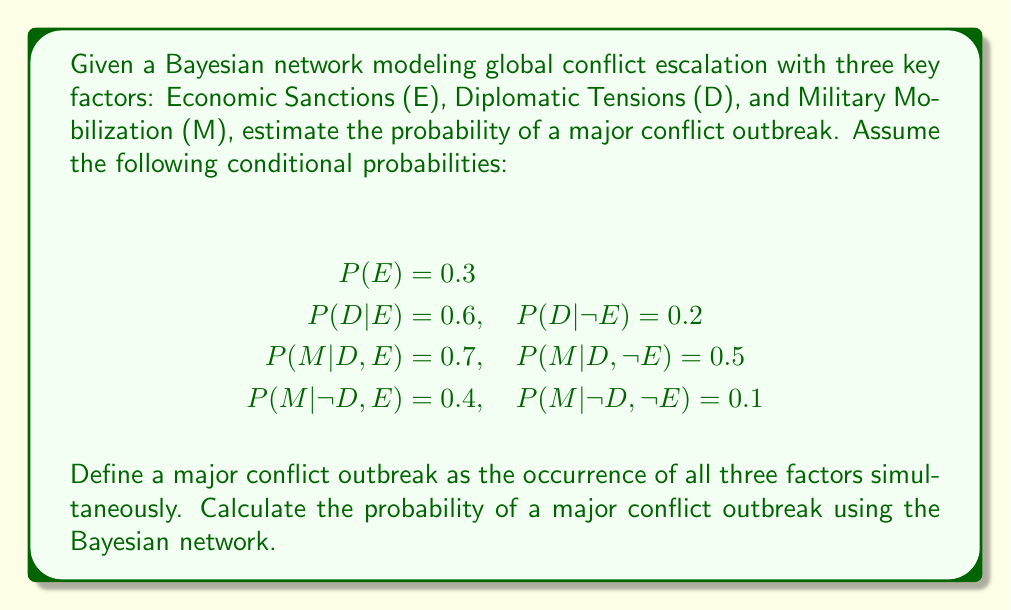Could you help me with this problem? To solve this problem, we'll use the chain rule of probability and the given conditional probabilities in the Bayesian network.

Step 1: Calculate P(E,D,M) using the chain rule
$$P(E,D,M) = P(E) \cdot P(D|E) \cdot P(M|D,E)$$

Step 2: Substitute the given probabilities
$$P(E,D,M) = 0.3 \cdot 0.6 \cdot 0.7$$

Step 3: Compute the final probability
$$P(E,D,M) = 0.3 \cdot 0.6 \cdot 0.7 = 0.126$$

Therefore, the probability of a major conflict outbreak (all three factors occurring simultaneously) is 0.126 or 12.6%.

Note: This simplified model assumes that a major conflict outbreak requires all three factors to be present. In reality, the relationship between these factors and conflict escalation is more complex and nuanced.
Answer: 0.126 